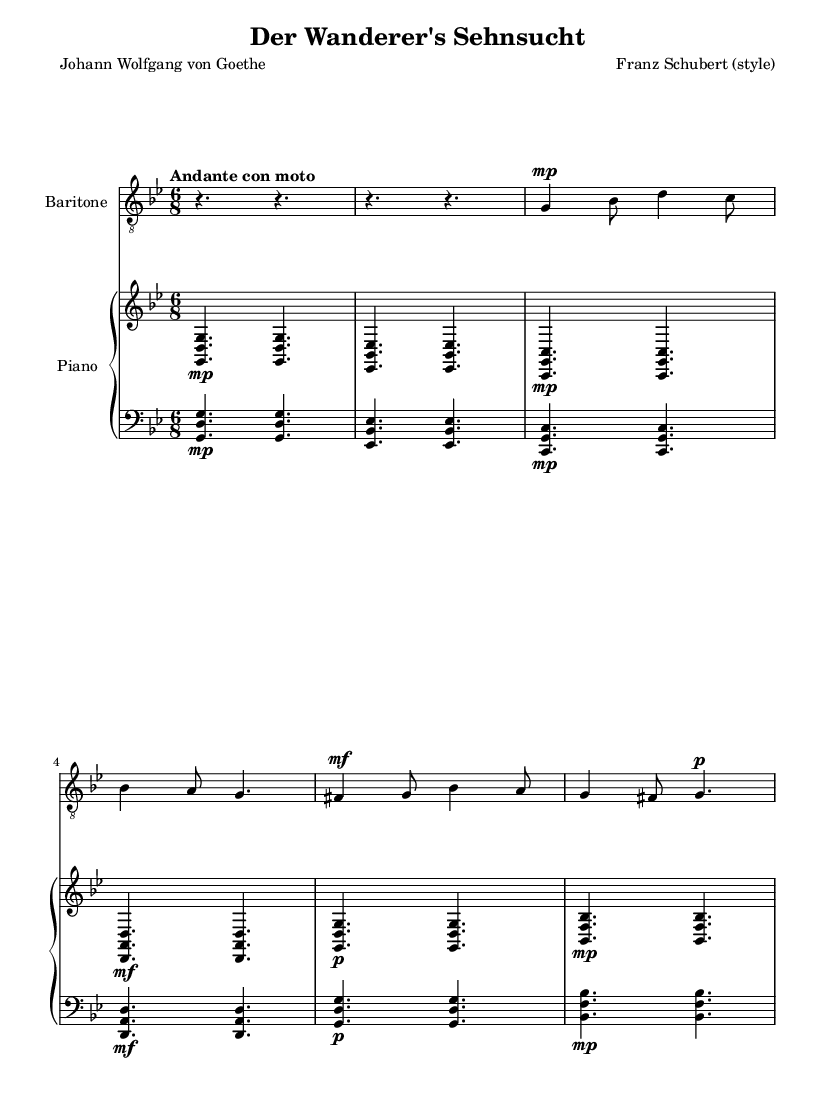What is the key signature of this music? The key signature in the music sheet shows two flats, indicating it is in G minor.
Answer: G minor What is the time signature of this music? The time signature is located at the beginning of the sheet music after the key signature. It is marked as 6/8.
Answer: 6/8 What is the tempo marking for this piece? The tempo marking is found at the start of the music, which indicates how fast or slow the piece should be played. It is marked "Andante con moto."
Answer: Andante con moto Which vocal part is indicated in the score? The score specifies the instrumental arrangement for voice, which is labeled as "Baritone." This is clearly indicated below the staff for voice.
Answer: Baritone How many staves are used for the piano part? The piano section is shown with two staves: one for the upper part and one for the lower part, represented in the score as "upper" and "lower" respectively.
Answer: Two staves What dynamic mark is indicated for the voice in the first measure? In the first measure for the voice, a dynamic marking of "mp" is present, indicating the volume should be mezzo-piano.
Answer: mp What is the first word of the lyrics? The lyrics start with the word "Nur," which is noted at the beginning of the lyric section.
Answer: Nur 